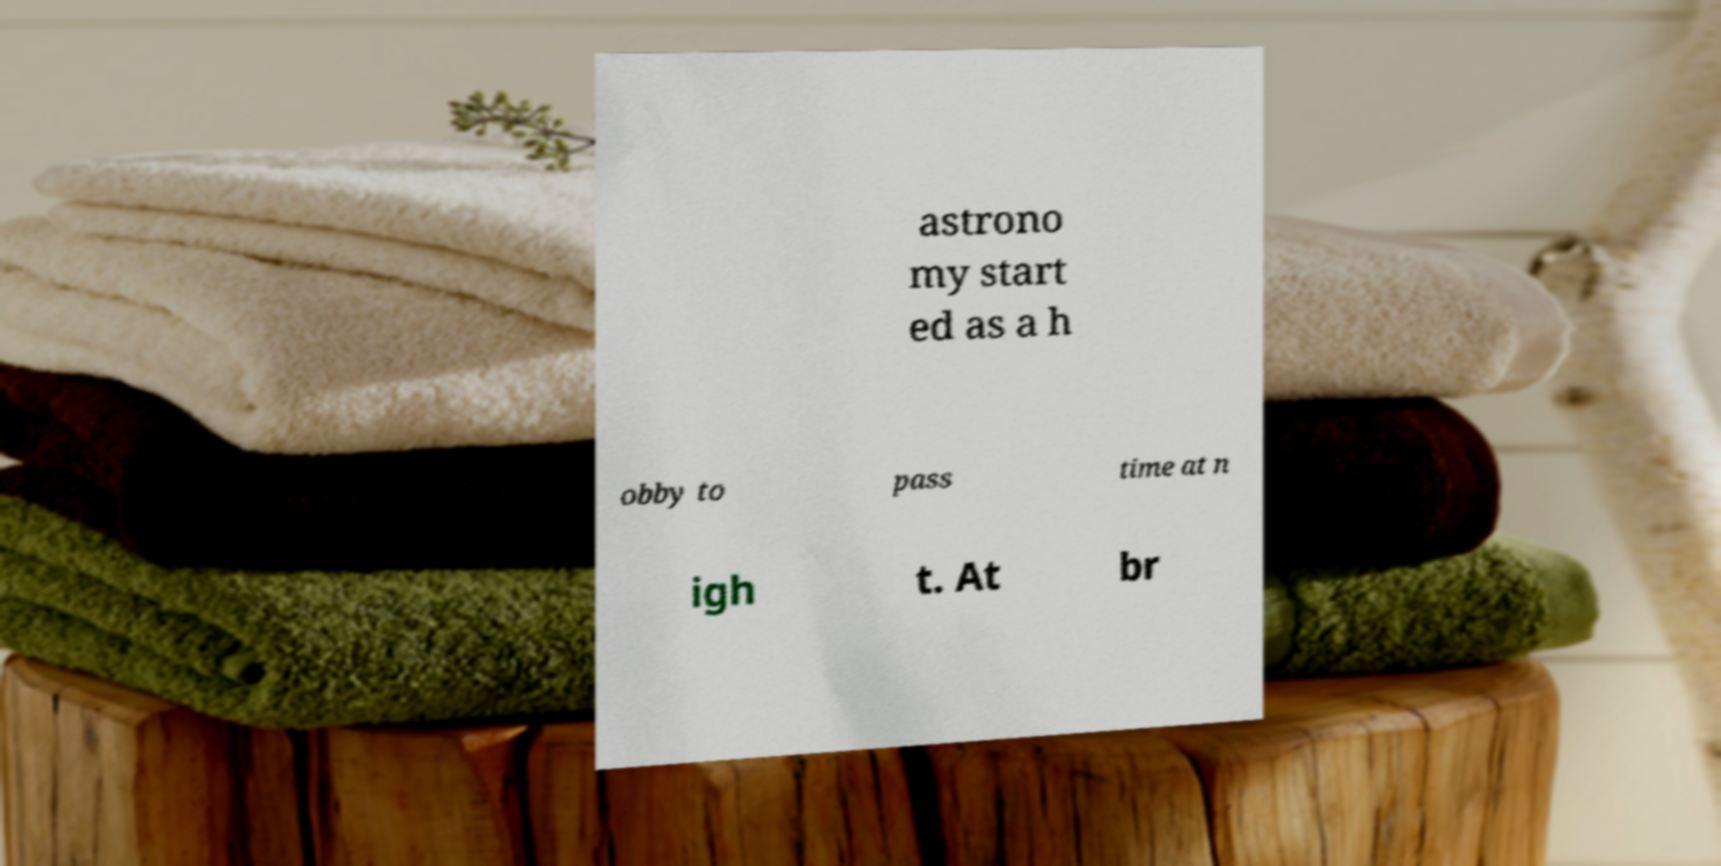I need the written content from this picture converted into text. Can you do that? astrono my start ed as a h obby to pass time at n igh t. At br 